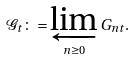Convert formula to latex. <formula><loc_0><loc_0><loc_500><loc_500>\mathcal { G } _ { t } \colon = \varprojlim _ { n \geq 0 } G _ { n t } .</formula> 